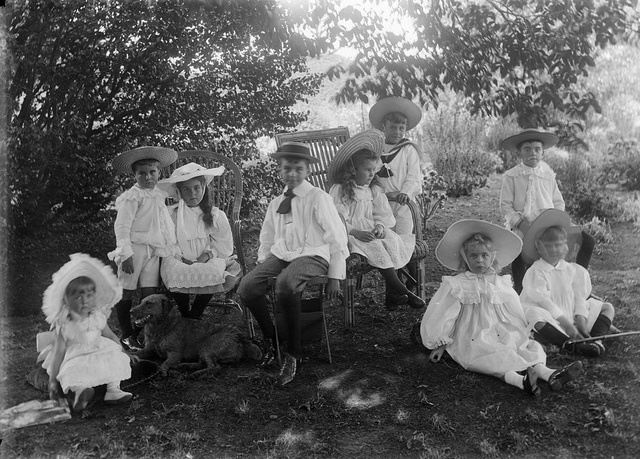Describe the objects in this image and their specific colors. I can see people in black, darkgray, gray, and lightgray tones, people in black, darkgray, gray, and lightgray tones, people in black, darkgray, gray, and lightgray tones, people in black, darkgray, gray, and lightgray tones, and people in black, darkgray, gray, and lightgray tones in this image. 